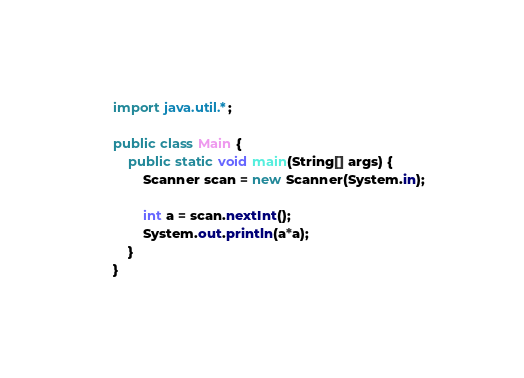<code> <loc_0><loc_0><loc_500><loc_500><_Java_>import java.util.*;

public class Main {
    public static void main(String[] args) {
        Scanner scan = new Scanner(System.in);

        int a = scan.nextInt();
        System.out.println(a*a);
    }
}</code> 